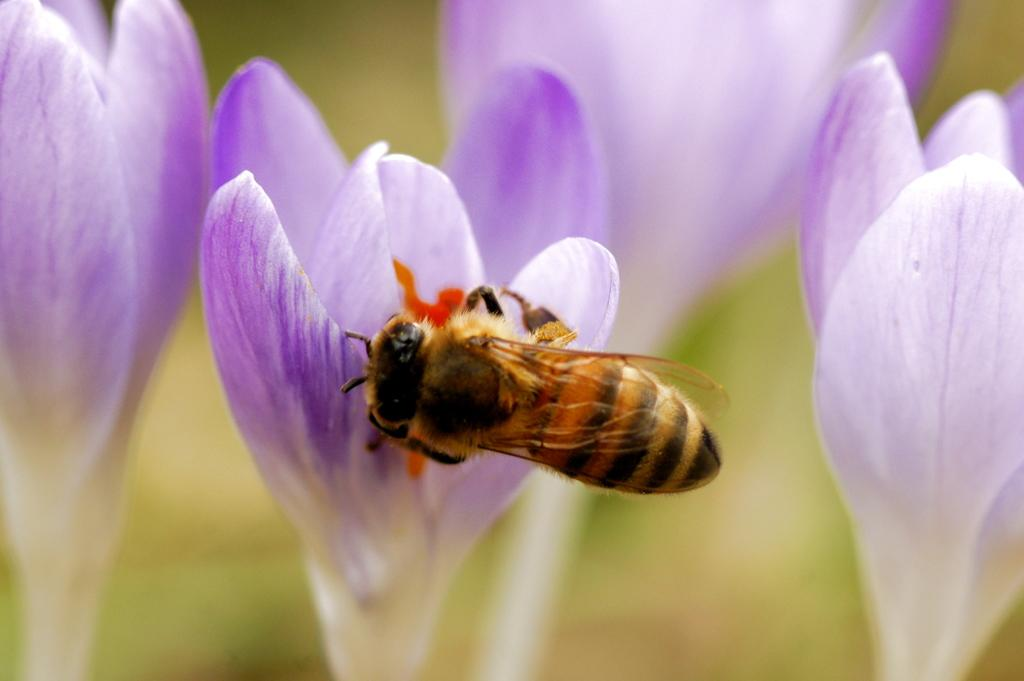What type of insect is in the image? There is a honey bee in the image. Where is the honey bee located? The honey bee is on a flower. Can you describe the flower the honey bee is on? The flower has purple and white colors. Are there any other flowers in the image? Yes, there are other flowers in the image. How would you describe the background of the image? The background of the image is blurred. What time of day does the honey bee die in the image? There is no indication in the image that the honey bee is dying, and therefore no such event can be observed. 